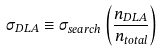Convert formula to latex. <formula><loc_0><loc_0><loc_500><loc_500>\sigma _ { D L A } \equiv \sigma _ { s e a r c h } \left ( \frac { n _ { D L A } } { n _ { t o t a l } } \right )</formula> 